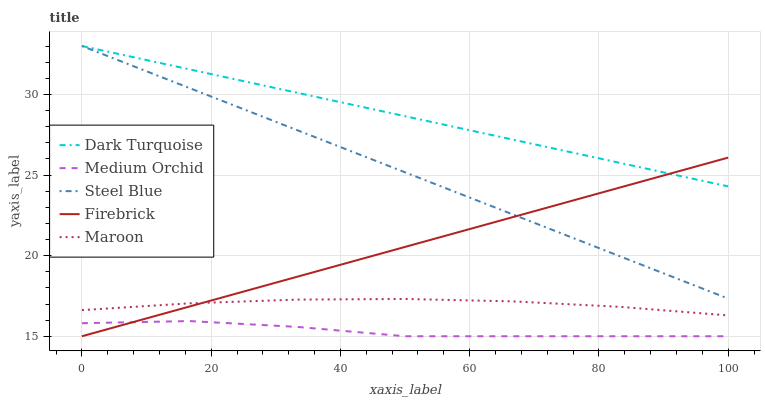Does Firebrick have the minimum area under the curve?
Answer yes or no. No. Does Firebrick have the maximum area under the curve?
Answer yes or no. No. Is Firebrick the smoothest?
Answer yes or no. No. Is Firebrick the roughest?
Answer yes or no. No. Does Steel Blue have the lowest value?
Answer yes or no. No. Does Firebrick have the highest value?
Answer yes or no. No. Is Medium Orchid less than Maroon?
Answer yes or no. Yes. Is Dark Turquoise greater than Medium Orchid?
Answer yes or no. Yes. Does Medium Orchid intersect Maroon?
Answer yes or no. No. 